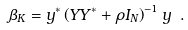Convert formula to latex. <formula><loc_0><loc_0><loc_500><loc_500>\beta _ { K } = { y } ^ { * } \left ( { Y Y } ^ { * } + \rho { I } _ { N } \right ) ^ { - 1 } { y } \ .</formula> 